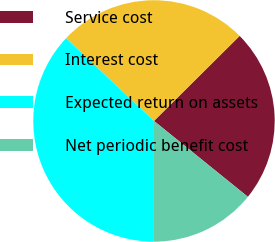<chart> <loc_0><loc_0><loc_500><loc_500><pie_chart><fcel>Service cost<fcel>Interest cost<fcel>Expected return on assets<fcel>Net periodic benefit cost<nl><fcel>23.26%<fcel>25.54%<fcel>37.01%<fcel>14.19%<nl></chart> 